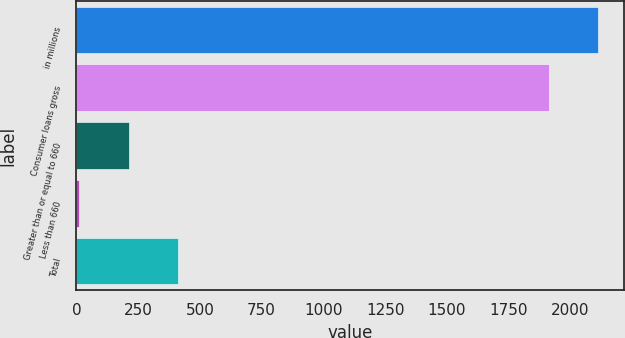<chart> <loc_0><loc_0><loc_500><loc_500><bar_chart><fcel>in millions<fcel>Consumer loans gross<fcel>Greater than or equal to 660<fcel>Less than 660<fcel>Total<nl><fcel>2112.6<fcel>1912<fcel>211.6<fcel>11<fcel>412.2<nl></chart> 